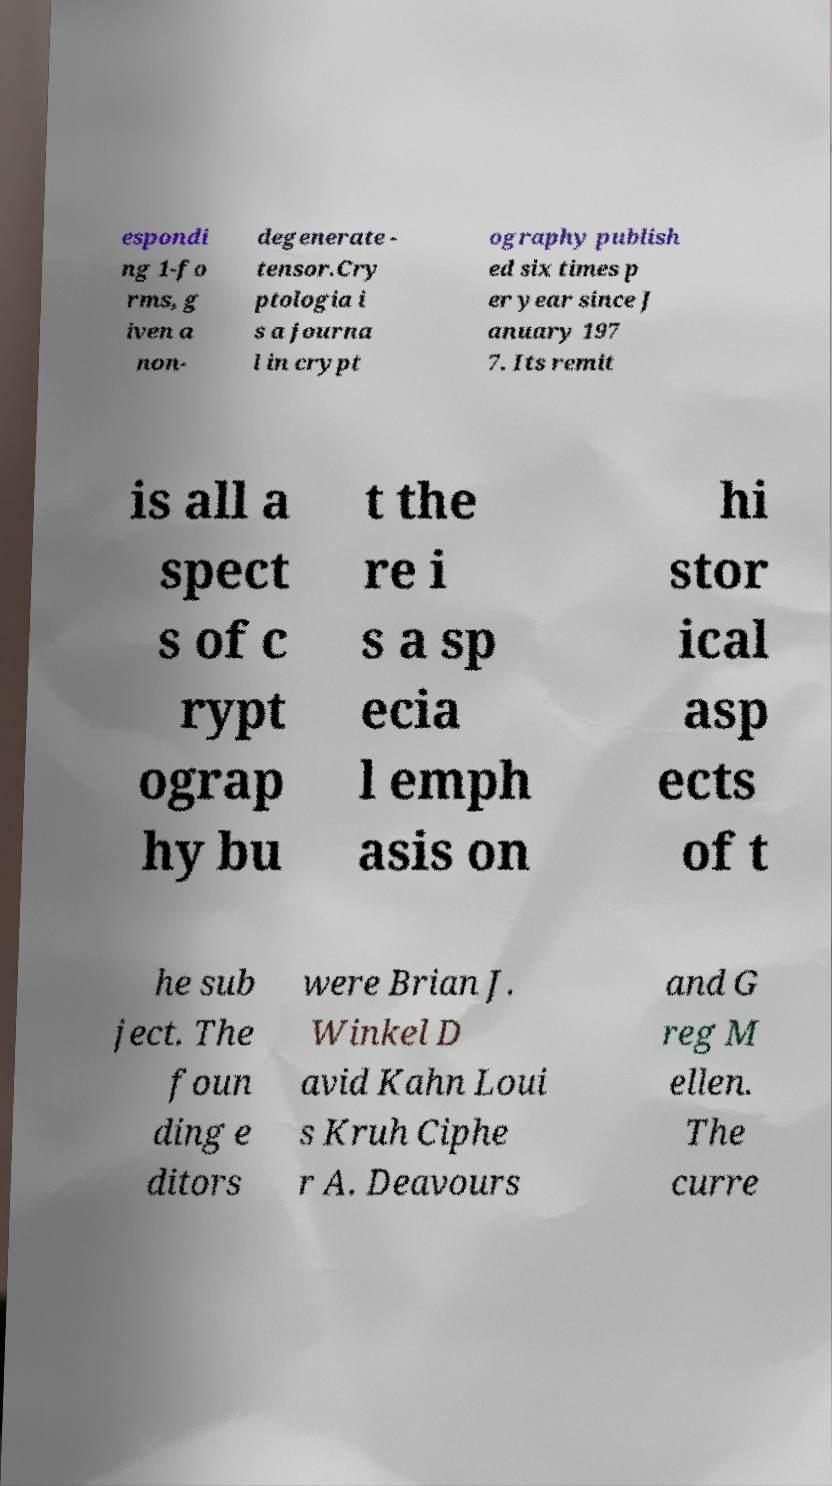What messages or text are displayed in this image? I need them in a readable, typed format. espondi ng 1-fo rms, g iven a non- degenerate - tensor.Cry ptologia i s a journa l in crypt ography publish ed six times p er year since J anuary 197 7. Its remit is all a spect s of c rypt ograp hy bu t the re i s a sp ecia l emph asis on hi stor ical asp ects of t he sub ject. The foun ding e ditors were Brian J. Winkel D avid Kahn Loui s Kruh Ciphe r A. Deavours and G reg M ellen. The curre 